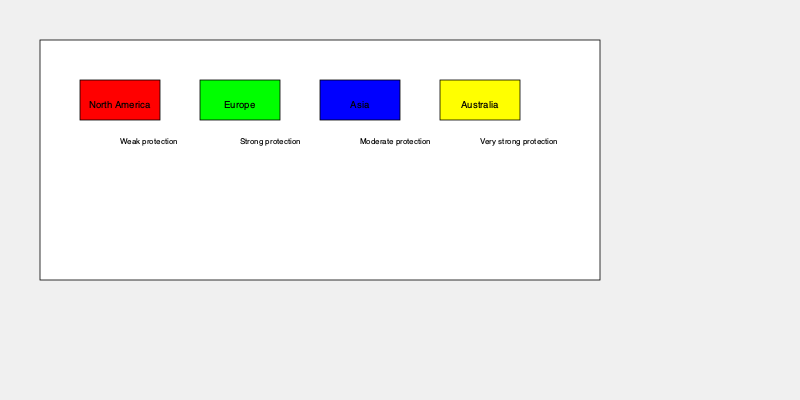Based on the world map showing animal protection laws in different regions, which area has the strongest animal welfare legislation, and what factors might contribute to this region's advanced animal protection policies? To answer this question, let's analyze the information provided in the world map:

1. The map shows four regions: North America, Europe, Asia, and Australia.
2. Each region is color-coded to represent the strength of their animal protection laws:
   - Red (North America): Weak protection
   - Green (Europe): Strong protection
   - Blue (Asia): Moderate protection
   - Yellow (Australia): Very strong protection

3. According to the color scheme, Australia has the strongest animal welfare legislation (yellow).

Factors that might contribute to Australia's advanced animal protection policies:

a) Historical context: Australia has a unique ecosystem and biodiversity, which may have led to a greater awareness of animal welfare issues.

b) Cultural values: Australian society generally places a high value on wildlife conservation and animal welfare.

c) Economic factors: As a developed nation, Australia has the resources to implement and enforce strong animal protection laws.

d) Political system: Australia's stable democratic system allows for the development and implementation of progressive policies.

e) Scientific research: Australian universities and research institutions contribute significantly to animal welfare science, influencing policy decisions.

f) International influence: Australia's participation in global animal welfare organizations and treaties may have encouraged the adoption of stringent protection measures.

g) Public awareness: Strong advocacy groups and media coverage of animal welfare issues may have increased public support for robust legislation.

h) Agricultural practices: As a major livestock producer, Australia may have developed strict animal welfare standards to maintain its reputation in international markets.

i) Geographical isolation: Australia's unique position as both a continent and a country may have facilitated the implementation of comprehensive, nation-wide animal protection laws.
Answer: Australia; factors include unique biodiversity, cultural values, economic resources, stable political system, scientific research, international influence, public awareness, agricultural practices, and geographical isolation. 